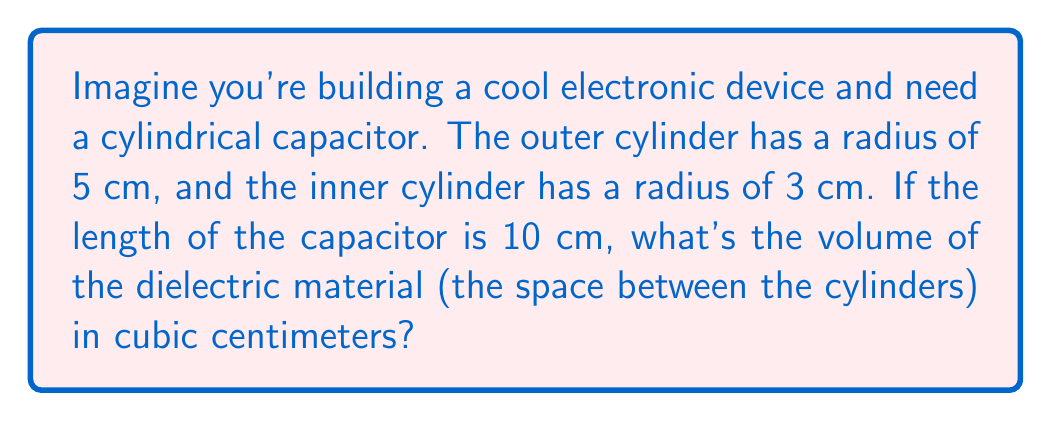Could you help me with this problem? Let's approach this step-by-step:

1) The volume of a cylinder is given by the formula:
   $$ V = \pi r^2 h $$
   where $r$ is the radius and $h$ is the height (or length) of the cylinder.

2) We need to find the volume of the outer cylinder and subtract the volume of the inner cylinder:
   $$ V_{dielectric} = V_{outer} - V_{inner} $$

3) For the outer cylinder:
   $$ V_{outer} = \pi (5\text{ cm})^2 (10\text{ cm}) = 250\pi \text{ cm}^3 $$

4) For the inner cylinder:
   $$ V_{inner} = \pi (3\text{ cm})^2 (10\text{ cm}) = 90\pi \text{ cm}^3 $$

5) Now, let's subtract:
   $$ V_{dielectric} = 250\pi \text{ cm}^3 - 90\pi \text{ cm}^3 = 160\pi \text{ cm}^3 $$

6) If we want to calculate the exact value:
   $$ 160\pi \approx 502.65 \text{ cm}^3 $$

[asy]
import geometry;

size(200);
draw(circle((0,0),5), blue);
draw(circle((0,0),3), red);
draw((5,0)--(5,10), blue);
draw((3,0)--(3,10), red);
draw((0,10)--(5,10), blue);
draw((0,10)--(3,10), red);
label("5 cm", (5.5,5), E);
label("3 cm", (3.5,5), E);
label("10 cm", (6,5), E);
[/asy]
Answer: $160\pi \text{ cm}^3$ or approximately $502.65 \text{ cm}^3$ 